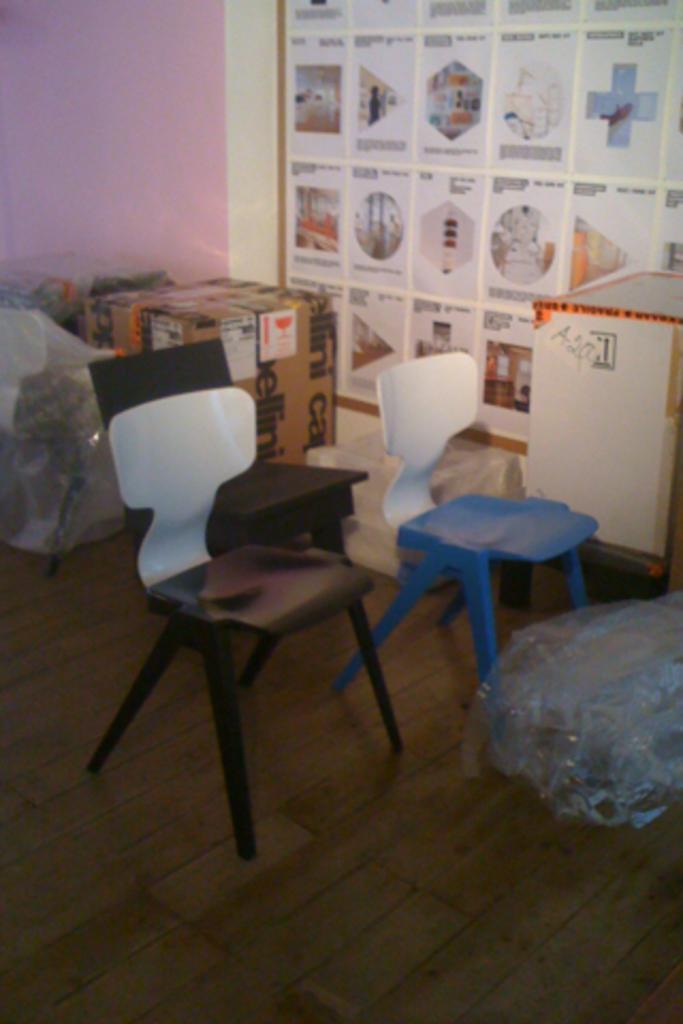Describe this image in one or two sentences. In this image there are three chairs and there are a few card boards and covers on the floor. In the background there is a poster with some images and text, is attached to the wall. 